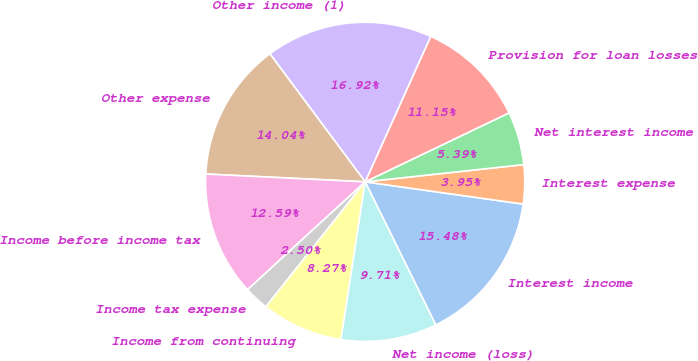Convert chart. <chart><loc_0><loc_0><loc_500><loc_500><pie_chart><fcel>Interest income<fcel>Interest expense<fcel>Net interest income<fcel>Provision for loan losses<fcel>Other income (1)<fcel>Other expense<fcel>Income before income tax<fcel>Income tax expense<fcel>Income from continuing<fcel>Net income (loss)<nl><fcel>15.48%<fcel>3.95%<fcel>5.39%<fcel>11.15%<fcel>16.92%<fcel>14.04%<fcel>12.59%<fcel>2.5%<fcel>8.27%<fcel>9.71%<nl></chart> 